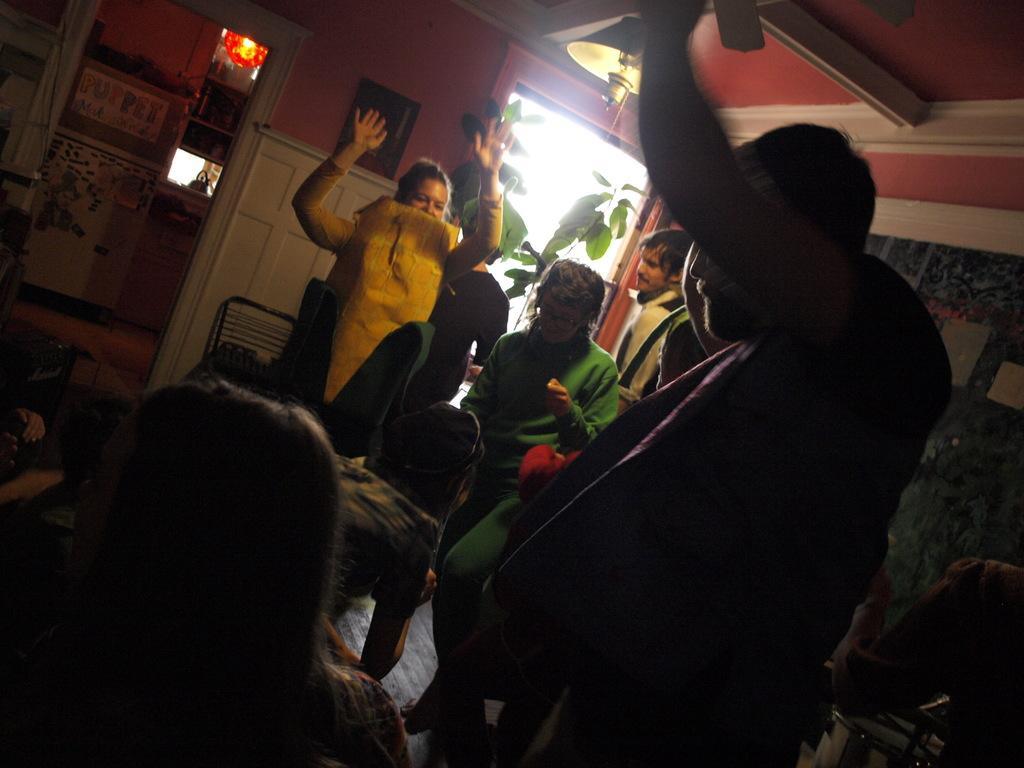Could you give a brief overview of what you see in this image? In this image I can see few people are wearing different color dresses. I can see few objects, plants, chair and the frame is attached to the wall. 